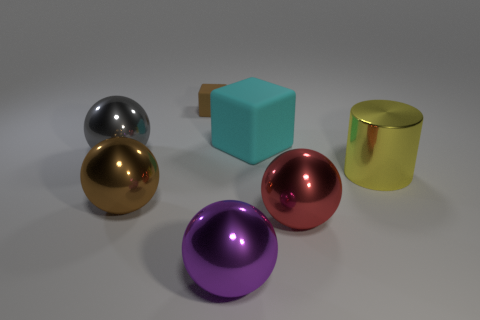What is the size of the other thing that is the same color as the small matte thing?
Your answer should be compact. Large. Is there a red cylinder that has the same material as the big brown sphere?
Give a very brief answer. No. The large rubber cube is what color?
Provide a succinct answer. Cyan. There is a thing behind the matte thing that is in front of the matte object that is behind the cyan block; what size is it?
Your answer should be very brief. Small. How many other things are there of the same shape as the purple metallic object?
Provide a succinct answer. 3. There is a large metallic object that is both to the right of the cyan matte block and left of the yellow cylinder; what color is it?
Make the answer very short. Red. Are there any other things that have the same size as the yellow object?
Provide a short and direct response. Yes. There is a matte block that is on the left side of the big purple metal ball; is it the same color as the big matte cube?
Provide a short and direct response. No. What number of balls are either brown metal things or red shiny objects?
Your response must be concise. 2. What shape is the large thing that is behind the gray thing?
Provide a succinct answer. Cube. 